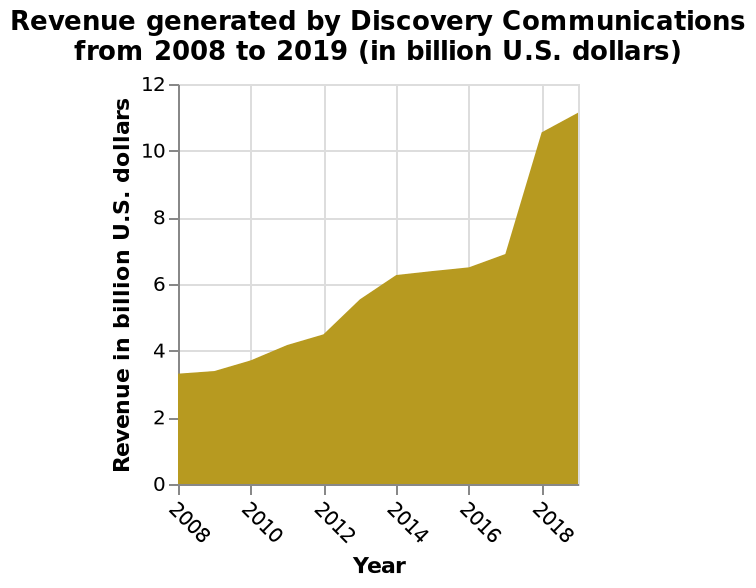<image>
What is the title of the area diagram?  The title of the area diagram is "Revenue generated by Discovery Communications from 2008 to 2019 (in billion U.S. dollars)." What does the x-axis represent in this diagram? The x-axis represents the Year, ranging from 2008 to 2018 on a linear scale. 